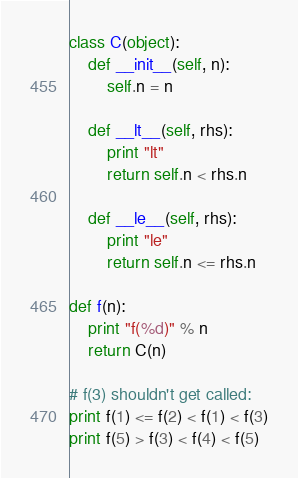<code> <loc_0><loc_0><loc_500><loc_500><_Python_>class C(object):
    def __init__(self, n):
        self.n = n

    def __lt__(self, rhs):
        print "lt"
        return self.n < rhs.n

    def __le__(self, rhs):
        print "le"
        return self.n <= rhs.n

def f(n):
    print "f(%d)" % n
    return C(n)

# f(3) shouldn't get called:
print f(1) <= f(2) < f(1) < f(3)
print f(5) > f(3) < f(4) < f(5)
</code> 